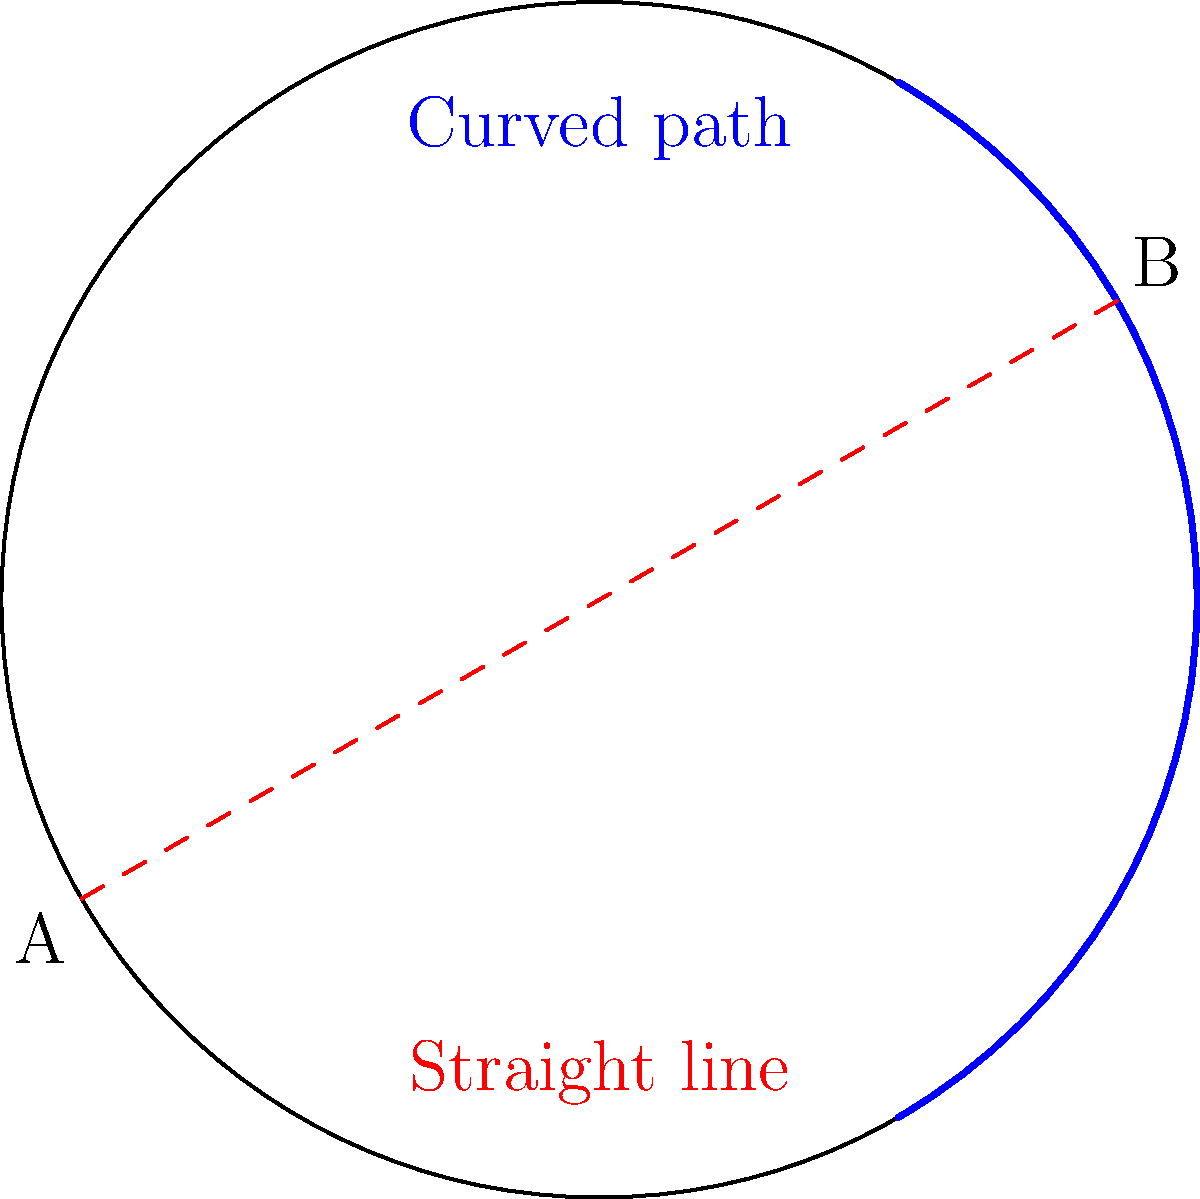Look at the picture of our Earth (represented by the circle). Imagine you want to travel from point A to point B. If you drew a straight line on a flat map, it would look like the red dashed line. But on our round Earth, the shortest path actually looks curved, like the blue line. Can you explain why the shortest path on a globe looks curved even though it's actually the straightest possible line between two points? Let's think about this step-by-step:

1. First, remember that the Earth is not flat, but round like a ball (or more precisely, an oblate spheroid).

2. On a flat surface, the shortest distance between two points is always a straight line. This is what we see with the red dashed line in the image.

3. However, on a curved surface like a globe, things work differently. The shortest path between two points on a sphere is called a "great circle."

4. A great circle is the largest circle that can be drawn on a sphere. It's like cutting the sphere exactly in half.

5. When we look at a great circle path on a flat map or from certain angles on a globe, it appears curved. This is because we're trying to represent a 3D curved surface (the globe) on a 2D flat surface.

6. The blue line in the image represents this great circle path. It's actually the straightest possible line on the surface of the sphere, even though it looks curved to us.

7. This curved appearance is a result of the projection of the 3D spherical surface onto a 2D plane (like our image or a flat map).

8. In real life, airplanes often follow these seemingly curved paths (great circles) because they are actually the shortest routes on our spherical Earth.

This phenomenon is part of what we study in non-Euclidean geometry, where the rules of flat (Euclidean) geometry don't always apply.
Answer: The shortest path appears curved due to the projection of a spherical surface onto a 2D plane. 